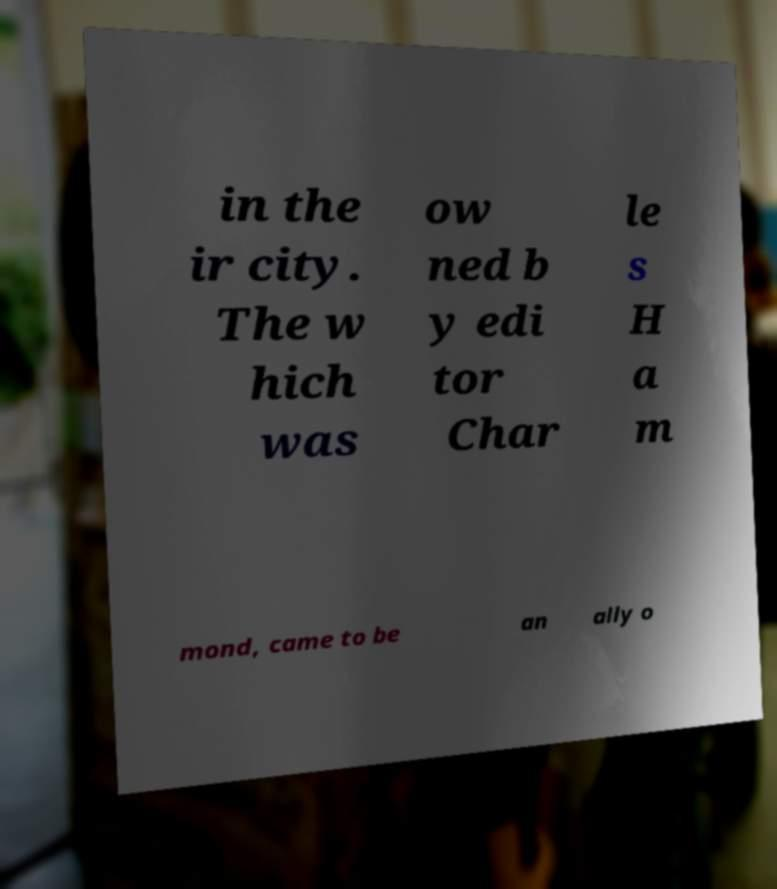There's text embedded in this image that I need extracted. Can you transcribe it verbatim? in the ir city. The w hich was ow ned b y edi tor Char le s H a m mond, came to be an ally o 